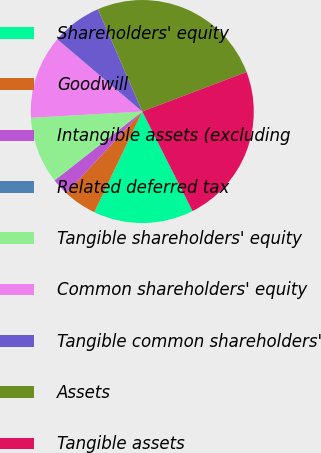Convert chart. <chart><loc_0><loc_0><loc_500><loc_500><pie_chart><fcel>Shareholders' equity<fcel>Goodwill<fcel>Intangible assets (excluding<fcel>Related deferred tax<fcel>Tangible shareholders' equity<fcel>Common shareholders' equity<fcel>Tangible common shareholders'<fcel>Assets<fcel>Tangible assets<nl><fcel>14.52%<fcel>4.86%<fcel>2.45%<fcel>0.03%<fcel>9.69%<fcel>12.11%<fcel>7.28%<fcel>25.74%<fcel>23.32%<nl></chart> 